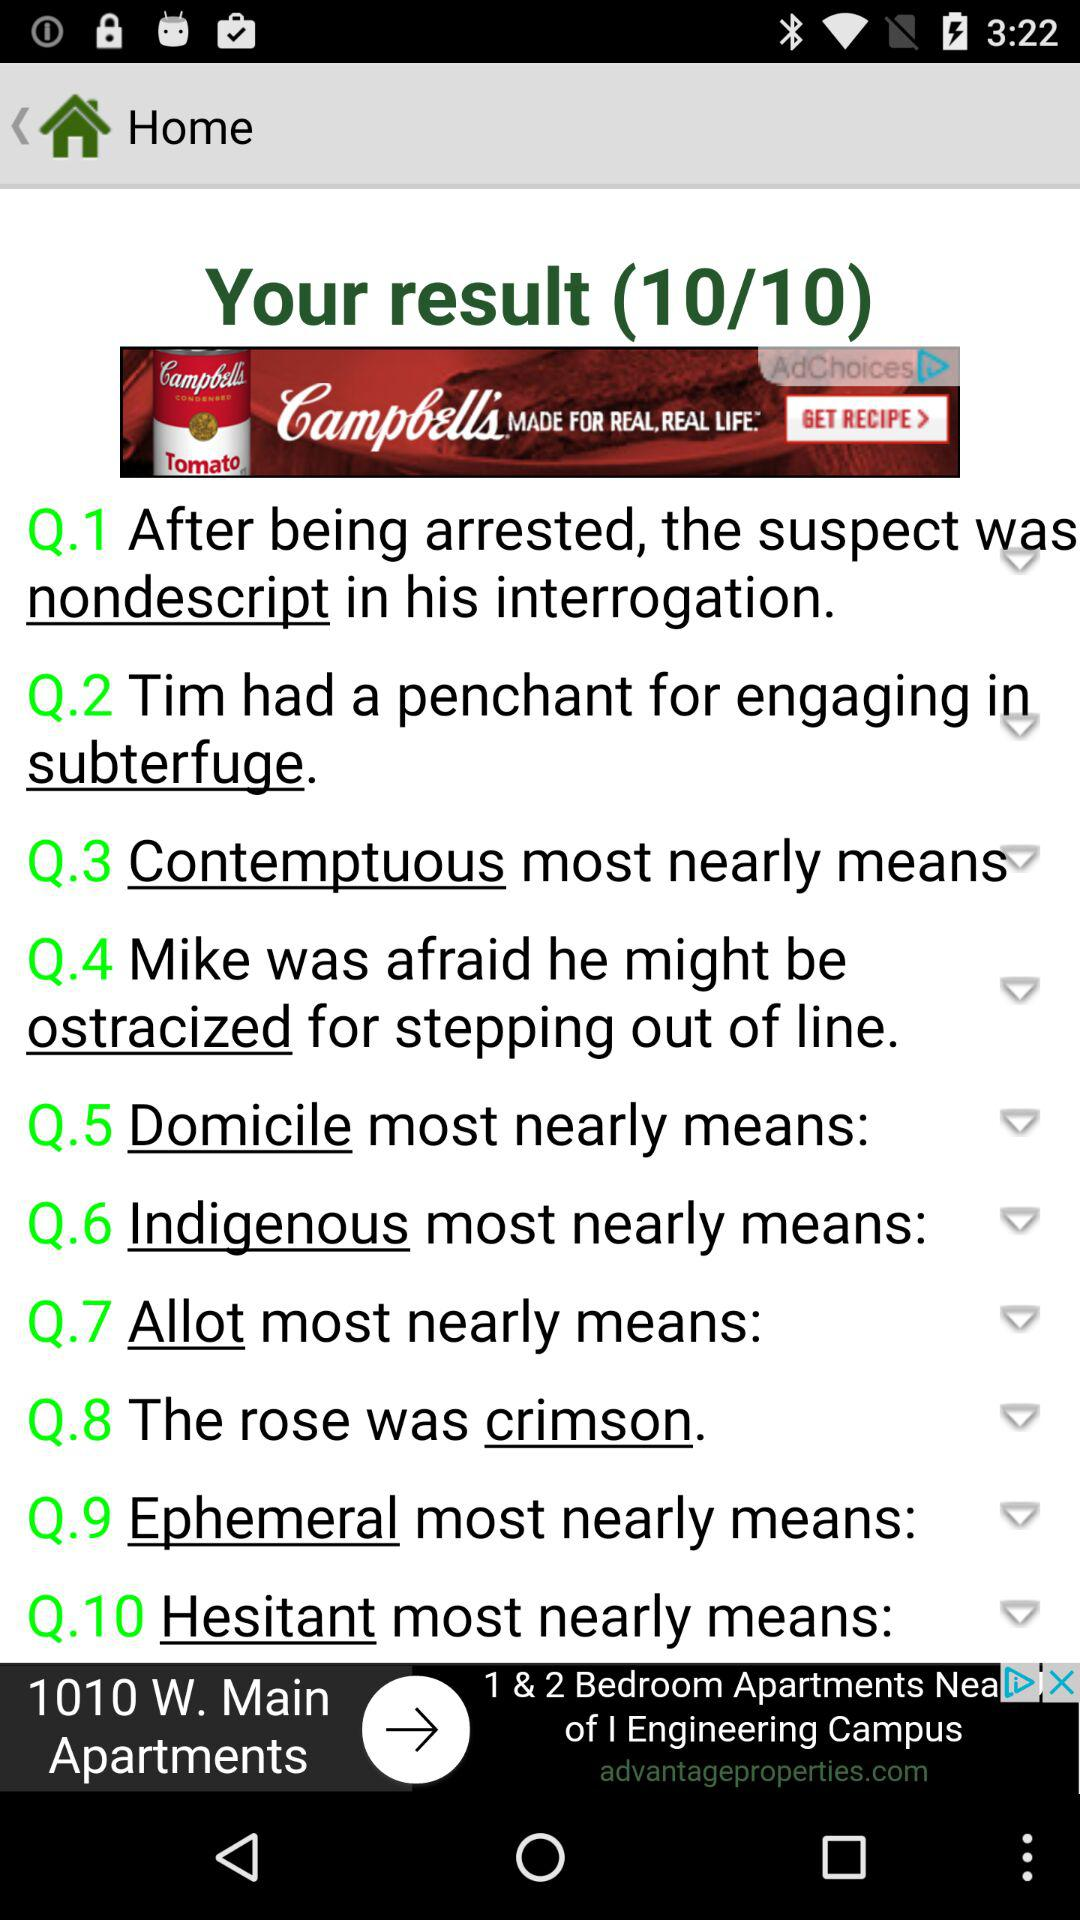How long did the user take to answer the questions?
When the provided information is insufficient, respond with <no answer>. <no answer> 